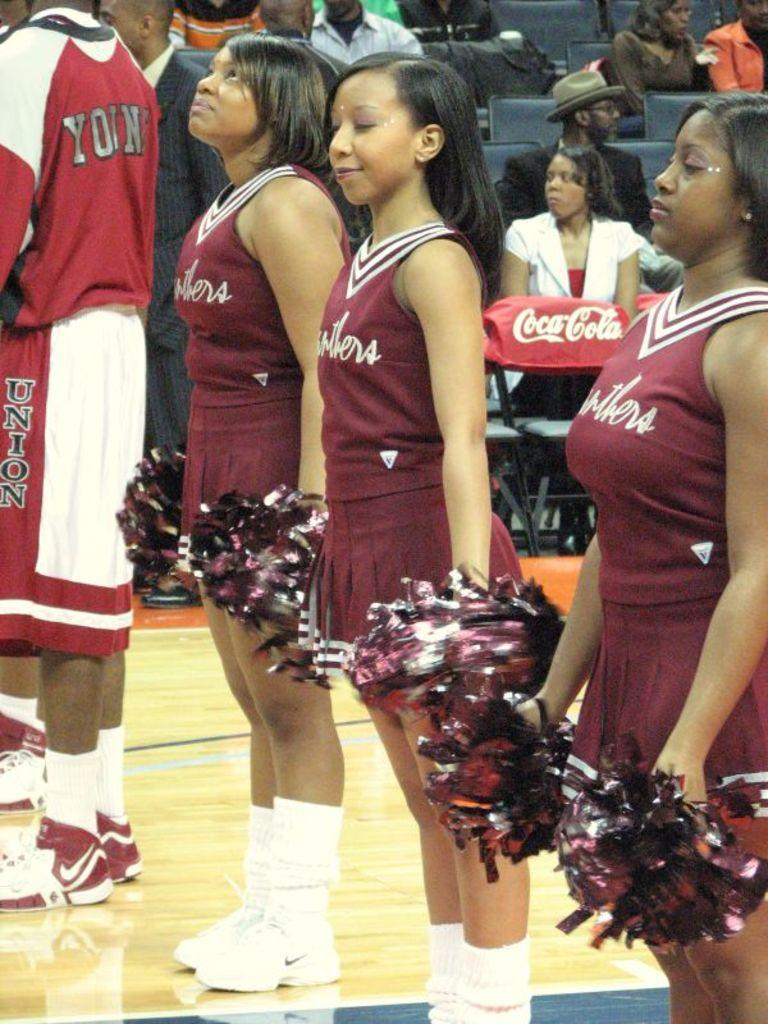<image>
Write a terse but informative summary of the picture. a line of cheerleaders standing on a court, with the sponsor coca cola behind them 